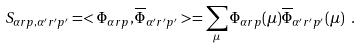<formula> <loc_0><loc_0><loc_500><loc_500>S _ { \alpha r p , \alpha ^ { \prime } r ^ { \prime } p ^ { \prime } } = < \Phi _ { \alpha r p } , \overline { \Phi } _ { \alpha ^ { \prime } r ^ { \prime } p ^ { \prime } } > = \sum _ { \mu } \Phi _ { \alpha r p } ( \mu ) \overline { \Phi } _ { \alpha ^ { \prime } r ^ { \prime } p ^ { \prime } } ( \mu ) \ .</formula> 